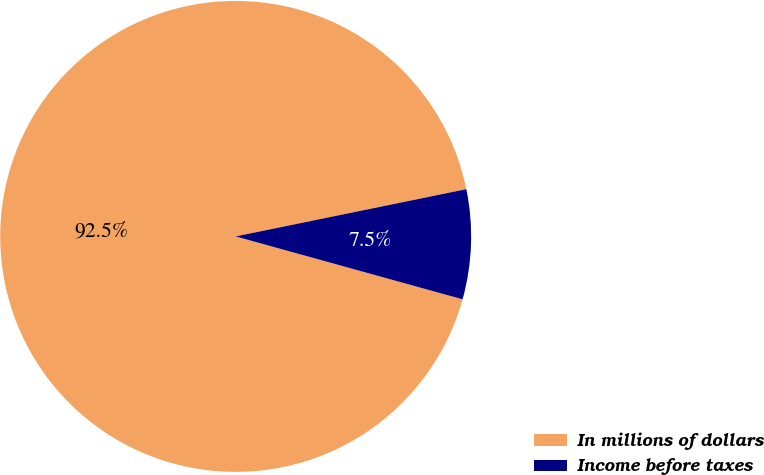<chart> <loc_0><loc_0><loc_500><loc_500><pie_chart><fcel>In millions of dollars<fcel>Income before taxes<nl><fcel>92.48%<fcel>7.52%<nl></chart> 